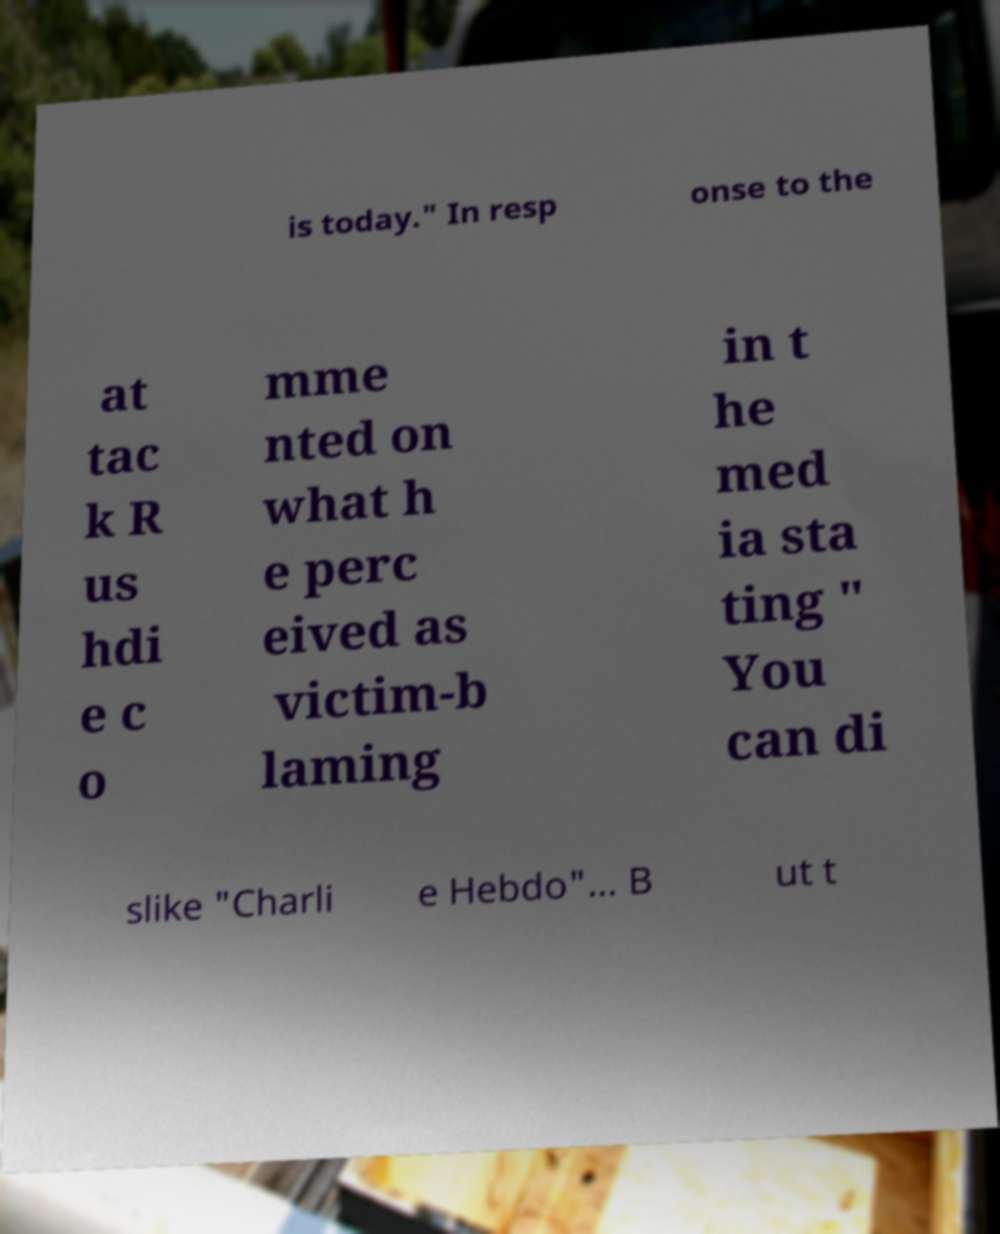Please identify and transcribe the text found in this image. is today." In resp onse to the at tac k R us hdi e c o mme nted on what h e perc eived as victim-b laming in t he med ia sta ting " You can di slike "Charli e Hebdo"... B ut t 